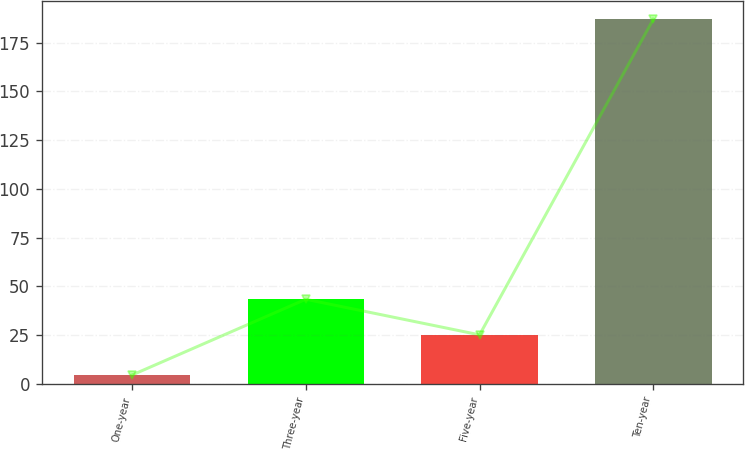<chart> <loc_0><loc_0><loc_500><loc_500><bar_chart><fcel>One-year<fcel>Three-year<fcel>Five-year<fcel>Ten-year<nl><fcel>4.6<fcel>43.44<fcel>25.2<fcel>187<nl></chart> 